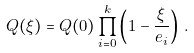<formula> <loc_0><loc_0><loc_500><loc_500>Q ( \xi ) = Q ( 0 ) \prod _ { i = 0 } ^ { k } \left ( 1 - \frac { \xi } { e _ { i } } \right ) \, .</formula> 